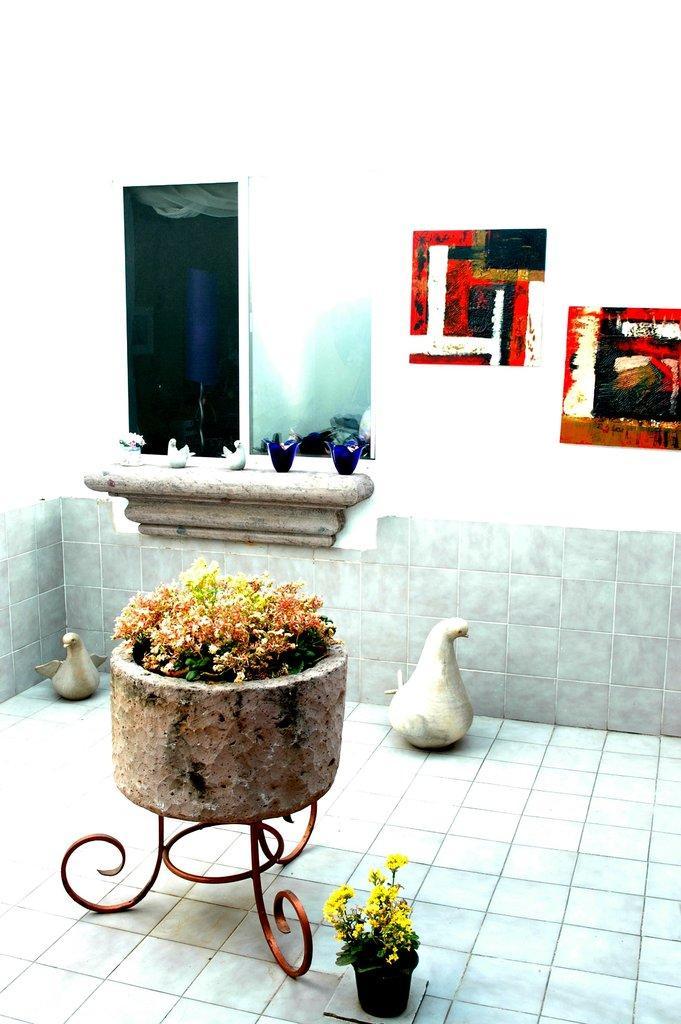Can you describe this image briefly? In the picture I can see a floral design pot on the left side. I can see a small flower pot on the floor and it is at the bottom of the picture. I can see the ceramic duck planters on the floor. I can see the glass window on the left side. 